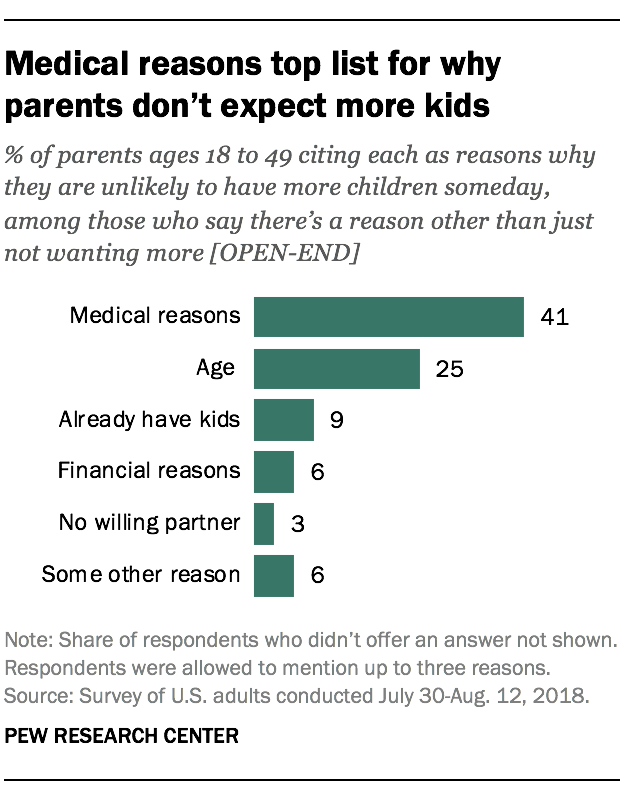Indicate a few pertinent items in this graphic. The value of the largest bar is 41, and it is true. There is a bar that has similar values to another bar. 